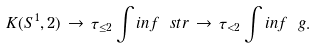Convert formula to latex. <formula><loc_0><loc_0><loc_500><loc_500>K ( S ^ { 1 } , 2 ) \, \rightarrow \, \tau _ { \leq 2 } \int i n f \ s t r \, \rightarrow \, \tau _ { < 2 } \int i n f \ g .</formula> 